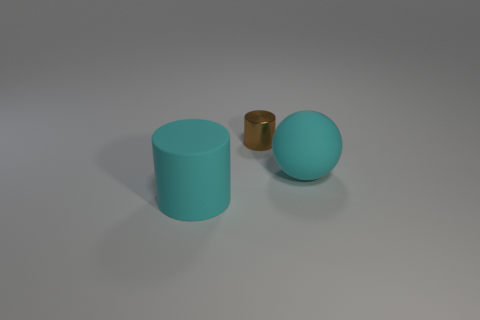Is there any other thing that has the same size as the shiny cylinder?
Provide a succinct answer. No. How many other things are the same size as the metal cylinder?
Your response must be concise. 0. The thing that is both behind the big matte cylinder and on the left side of the rubber ball is made of what material?
Give a very brief answer. Metal. Do the tiny thing right of the cyan cylinder and the big cyan thing to the left of the cyan matte ball have the same shape?
Ensure brevity in your answer.  Yes. Are there any other things that have the same material as the small brown thing?
Make the answer very short. No. There is a big thing in front of the rubber thing right of the big cyan matte object that is left of the sphere; what is its shape?
Provide a succinct answer. Cylinder. What number of other things are there of the same shape as the tiny metallic object?
Your response must be concise. 1. The thing that is the same size as the cyan ball is what color?
Offer a terse response. Cyan. What number of blocks are either blue rubber things or large cyan matte things?
Your answer should be very brief. 0. What number of brown cylinders are there?
Offer a terse response. 1. 